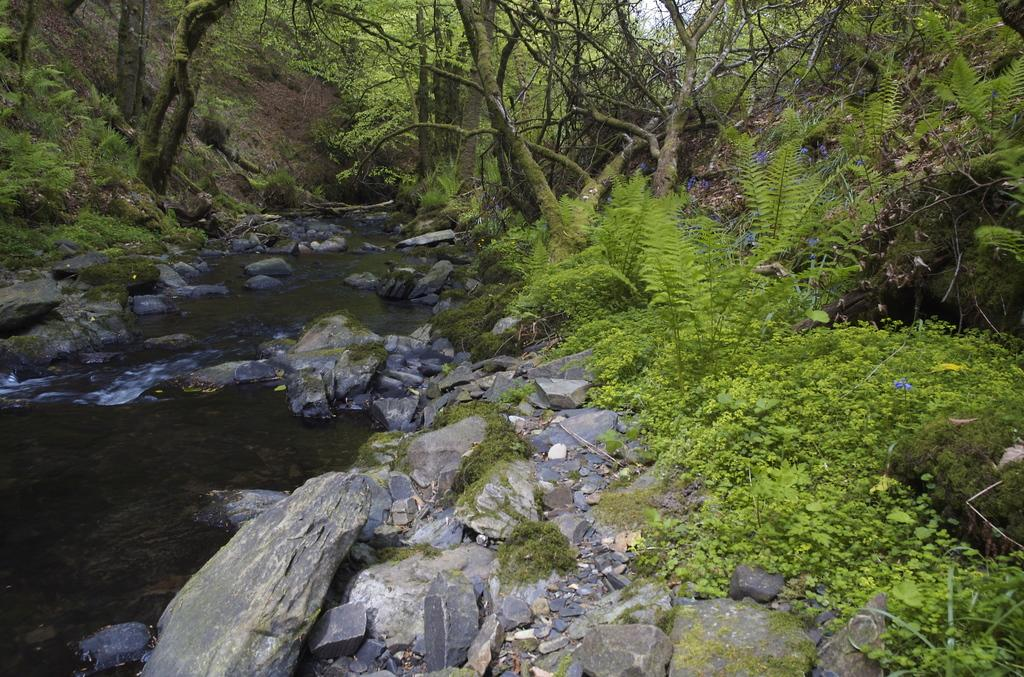What type of natural elements can be seen in the image? There are stones, plants, and trees visible in the image. Where is the water located in the image? The water is visible on the left side of the image. What type of bed can be seen in the image? There is no bed present in the image; it features stones, plants, trees, and water. 